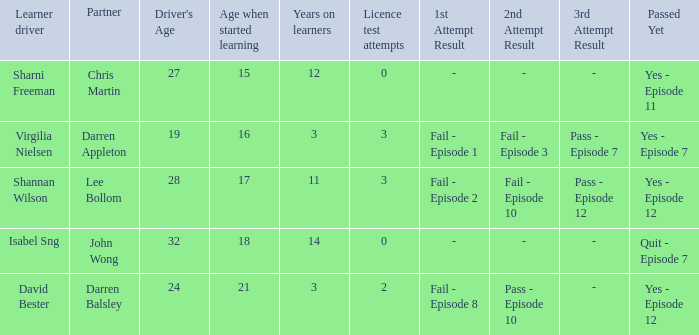What is the average number of years on learners of the drivers over the age of 24 with less than 0 attempts at the licence test? None. 